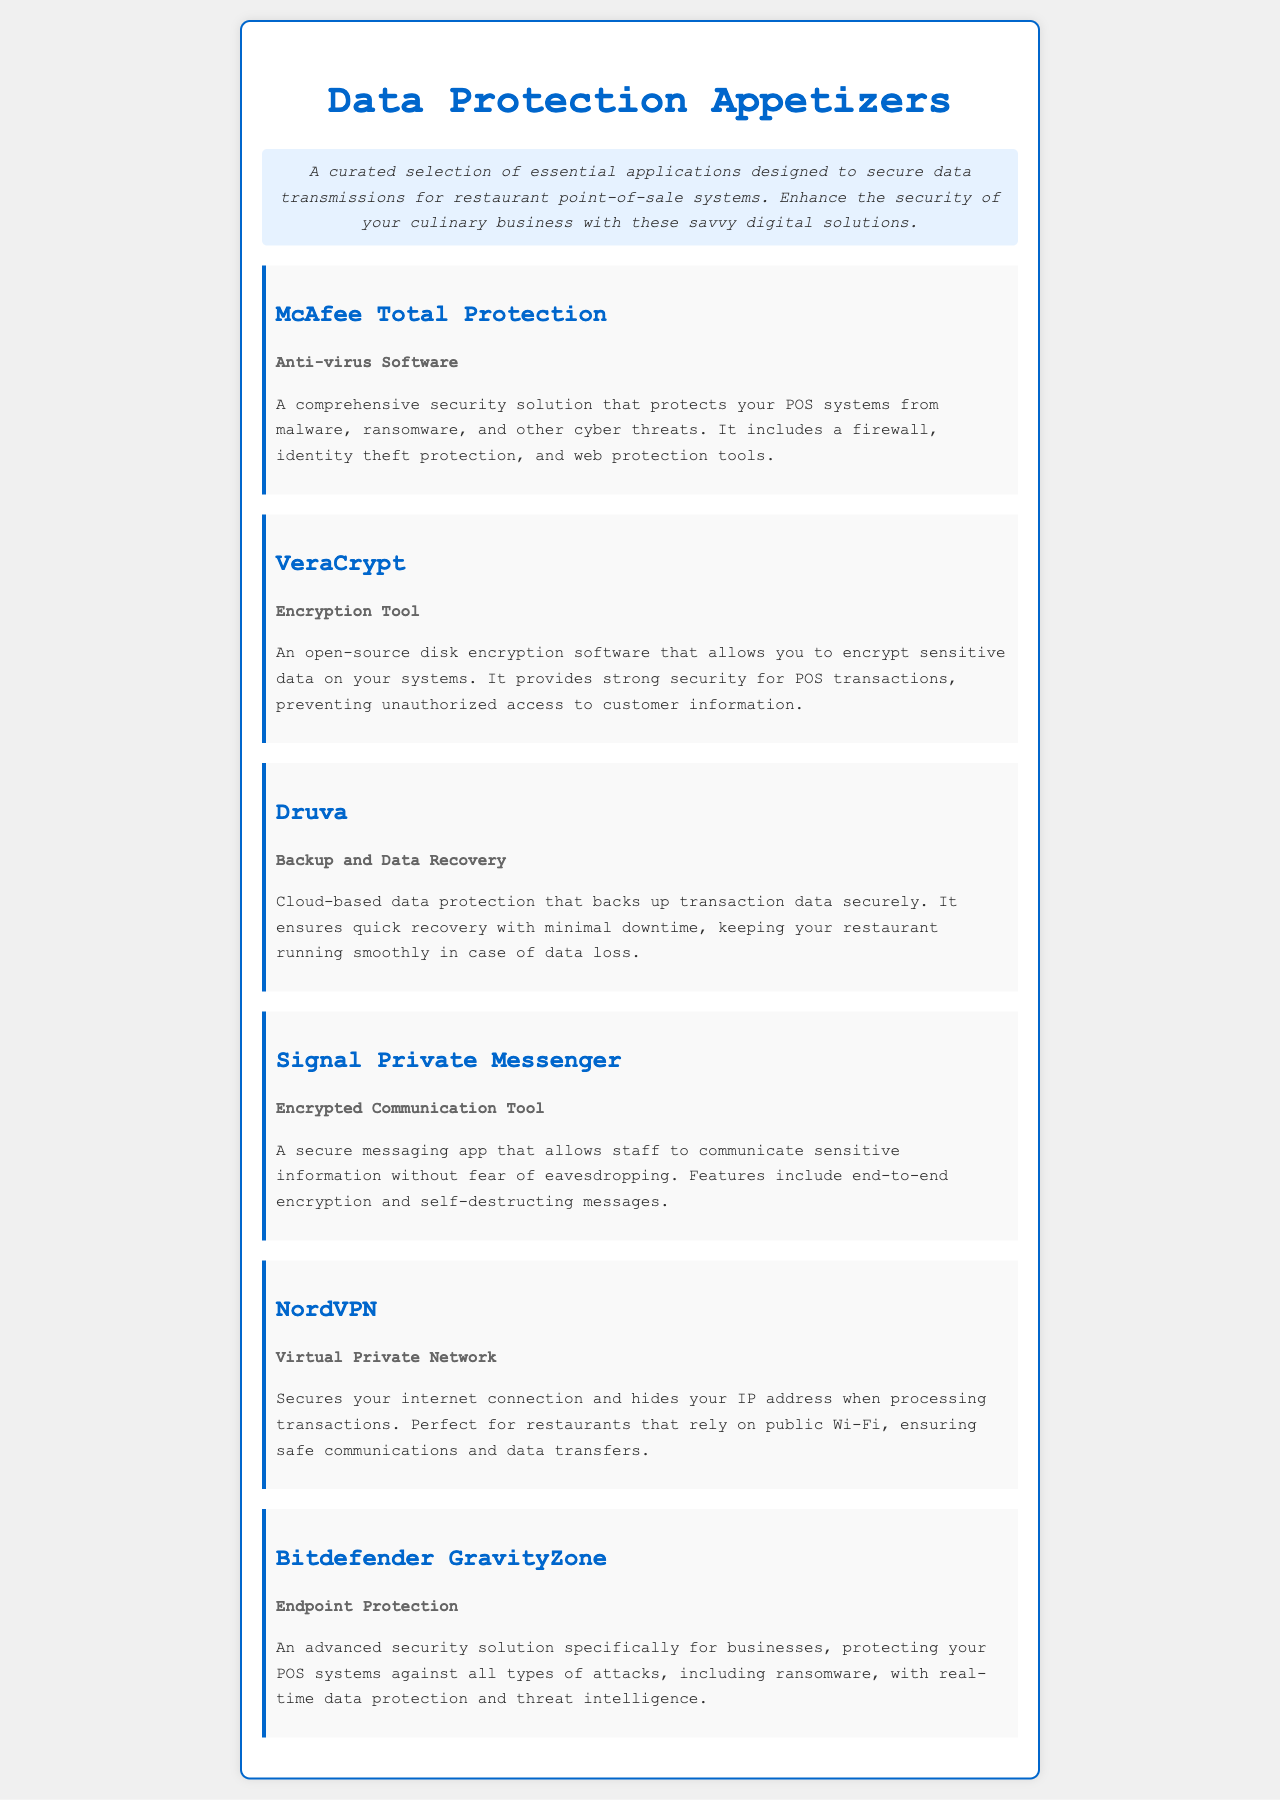what is the title of the document? The title of the document is indicated in the <title> tag within the HTML structure, which is "Data Protection Appetizers."
Answer: Data Protection Appetizers what type of application is McAfee Total Protection? The type of application is listed in the document as "Anti-virus Software."
Answer: Anti-virus Software what is the main purpose of VeraCrypt? The main purpose is described as providing encryption for sensitive data on systems, particularly to secure POS transactions.
Answer: Encrypt sensitive data which app offers encrypted communication? The app that offers encrypted communication is explicitly mentioned as "Signal Private Messenger."
Answer: Signal Private Messenger how many types of data protection applications are listed? The number can be derived from counting the different appetizers in the document, which total to six unique apps listed.
Answer: Six what security feature does NordVPN provide? NordVPN secures internet connections and hides IP addresses, as stated in the details.
Answer: Secures internet connection what unique feature does Druva provide? Druva provides cloud-based data protection and quick recovery for backing up transaction data.
Answer: Cloud-based data protection what type of protection does Bitdefender GravityZone offer? Bitdefender GravityZone offers "Endpoint Protection" to protect against various types of attacks.
Answer: Endpoint Protection 